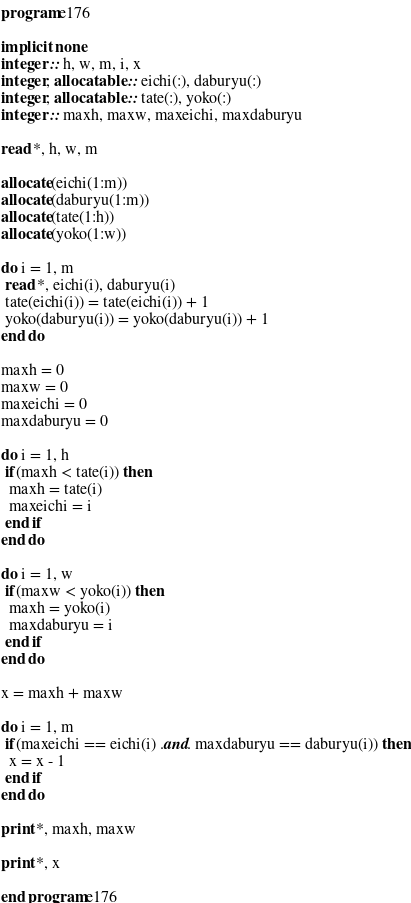Convert code to text. <code><loc_0><loc_0><loc_500><loc_500><_FORTRAN_>program e176
 
implicit none
integer :: h, w, m, i, x
integer, allocatable :: eichi(:), daburyu(:)
integer, allocatable :: tate(:), yoko(:)
integer :: maxh, maxw, maxeichi, maxdaburyu
 
read *, h, w, m

allocate(eichi(1:m))
allocate(daburyu(1:m))
allocate(tate(1:h))
allocate(yoko(1:w))

do i = 1, m
 read *, eichi(i), daburyu(i)
 tate(eichi(i)) = tate(eichi(i)) + 1
 yoko(daburyu(i)) = yoko(daburyu(i)) + 1
end do

maxh = 0
maxw = 0
maxeichi = 0
maxdaburyu = 0

do i = 1, h
 if(maxh < tate(i)) then
  maxh = tate(i)
  maxeichi = i
 end if
end do
 
do i = 1, w
 if(maxw < yoko(i)) then
  maxh = yoko(i)
  maxdaburyu = i
 end if
end do

x = maxh + maxw

do i = 1, m
 if(maxeichi == eichi(i) .and. maxdaburyu == daburyu(i)) then
  x = x - 1
 end if
end do

print *, maxh, maxw

print *, x

end program e176</code> 